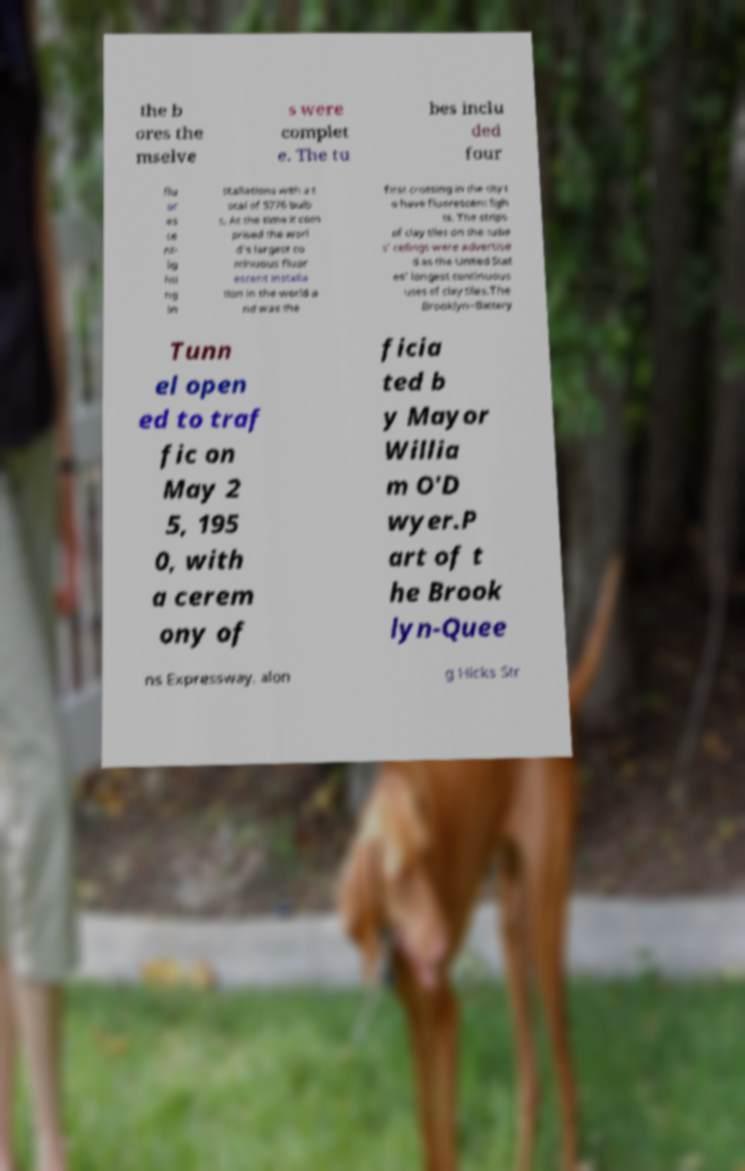There's text embedded in this image that I need extracted. Can you transcribe it verbatim? the b ores the mselve s were complet e. The tu bes inclu ded four flu or es ce nt- lig hti ng in stallations with a t otal of 5776 bulb s. At the time it com prised the worl d's largest co ntinuous fluor escent installa tion in the world a nd was the first crossing in the city t o have fluorescent ligh ts. The strips of clay tiles on the tube s' ceilings were advertise d as the United Stat es' longest continuous uses of clay tiles.The Brooklyn–Battery Tunn el open ed to traf fic on May 2 5, 195 0, with a cerem ony of ficia ted b y Mayor Willia m O'D wyer.P art of t he Brook lyn-Quee ns Expressway, alon g Hicks Str 